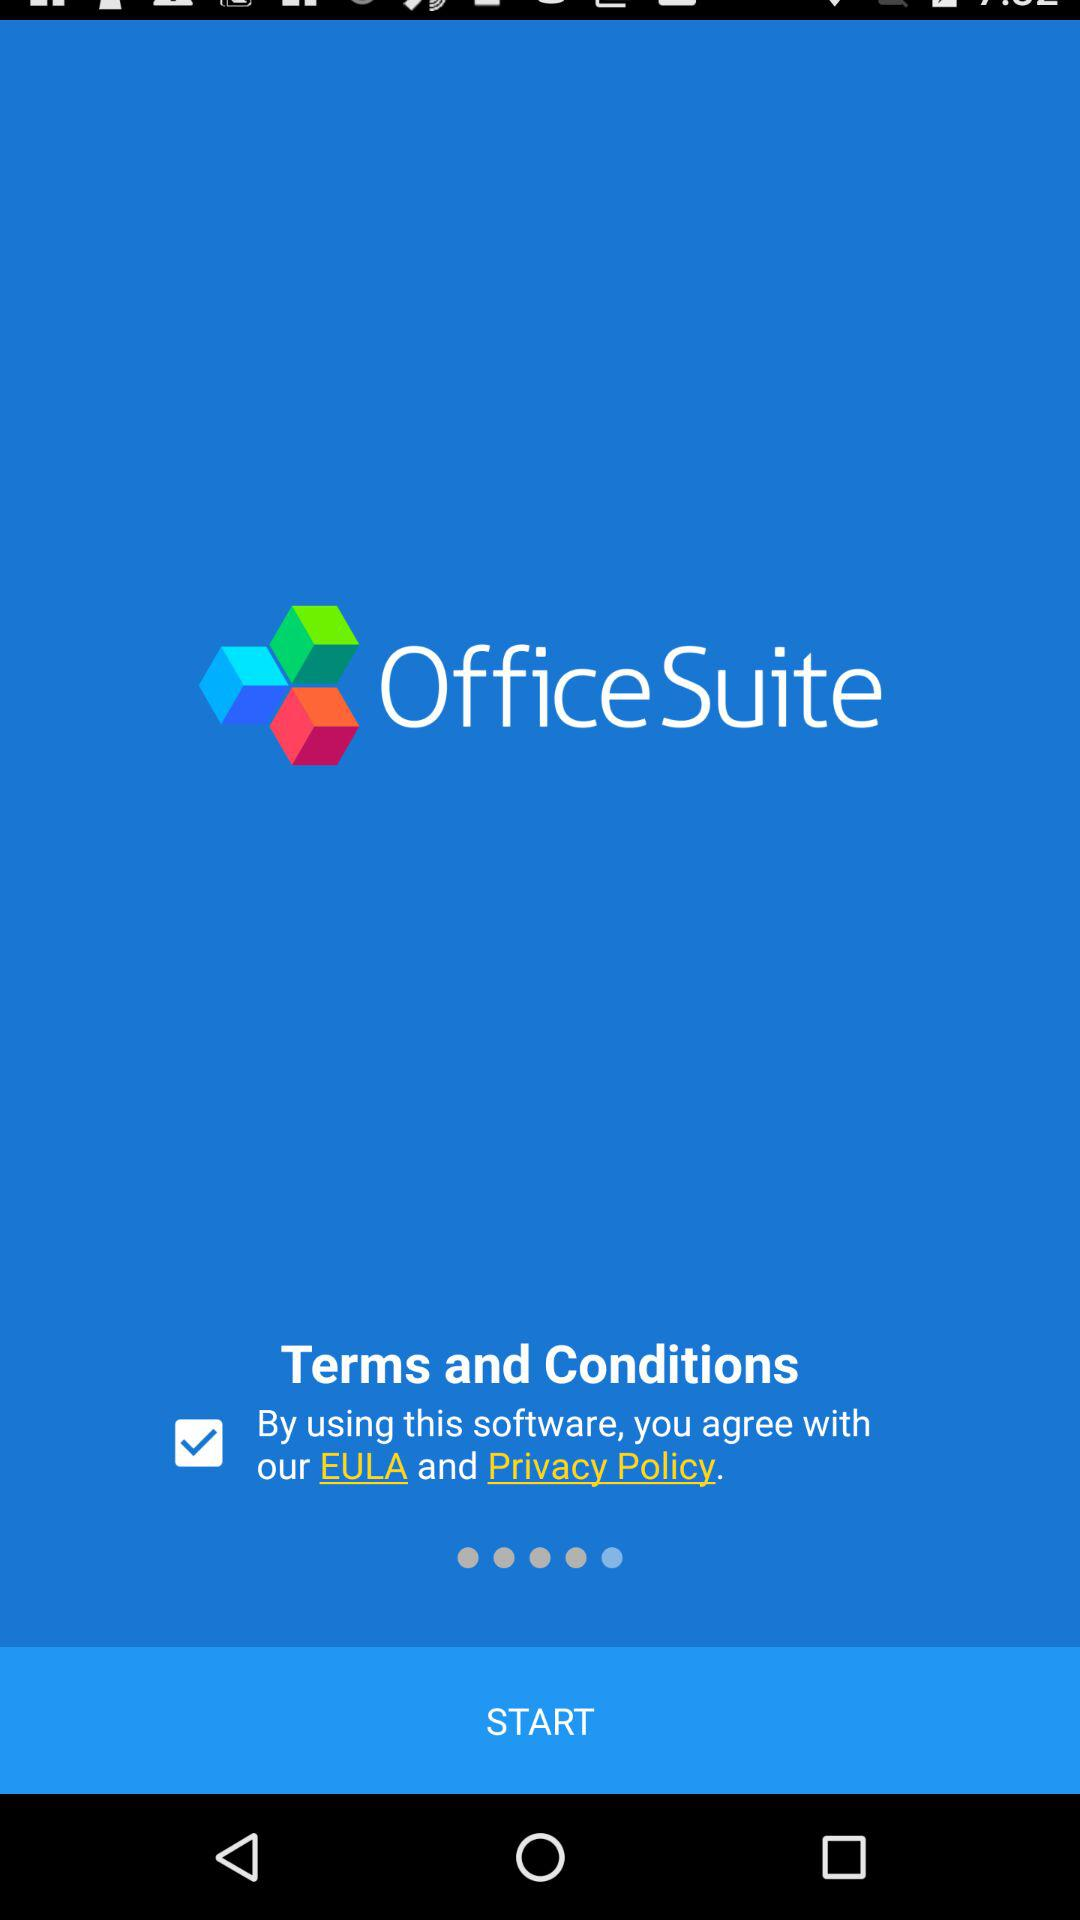What is the status of "By using this software, you agree with our EULA and Privacy and Policy"? The status is "on". 